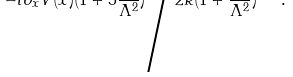Convert formula to latex. <formula><loc_0><loc_0><loc_500><loc_500>- i \partial _ { x } V ( x ) ( 1 + 5 \frac { k ^ { 2 } } { \Lambda ^ { 2 } } ) \Big { / } 2 k ( 1 + \frac { k ^ { 2 } } { \Lambda ^ { 2 } } ) \ \ .</formula> 